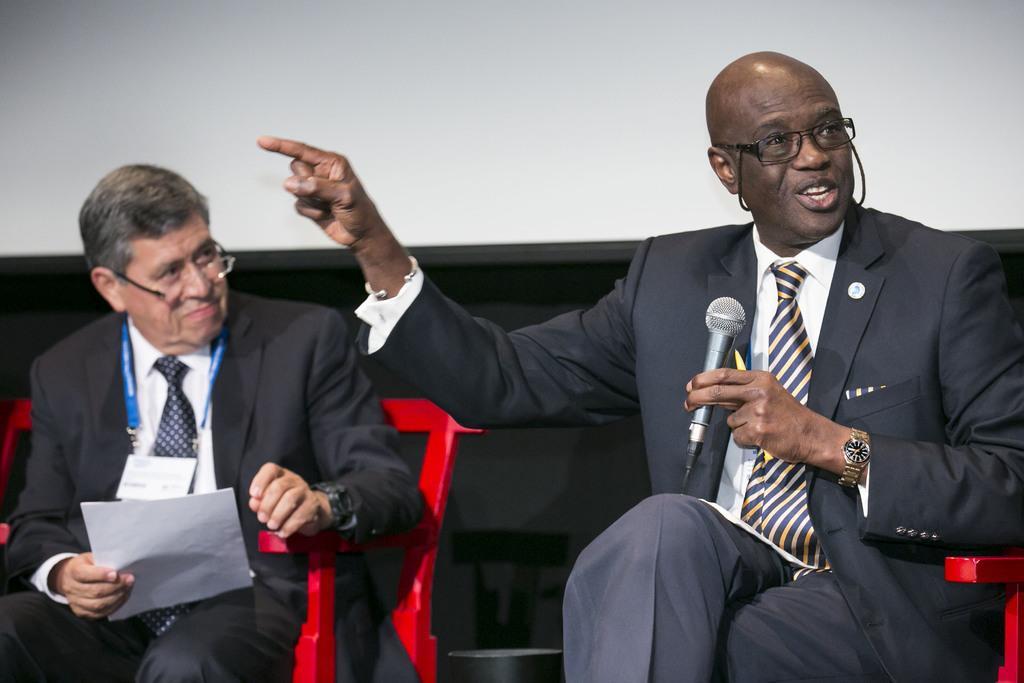In one or two sentences, can you explain what this image depicts? In this image there are persons sitting. On the right side there is a man sitting and holding a mic and speaking. On the left side there is a man sitting on chair and holding a paper in his hand. In the background there is an object which is black in colour. 